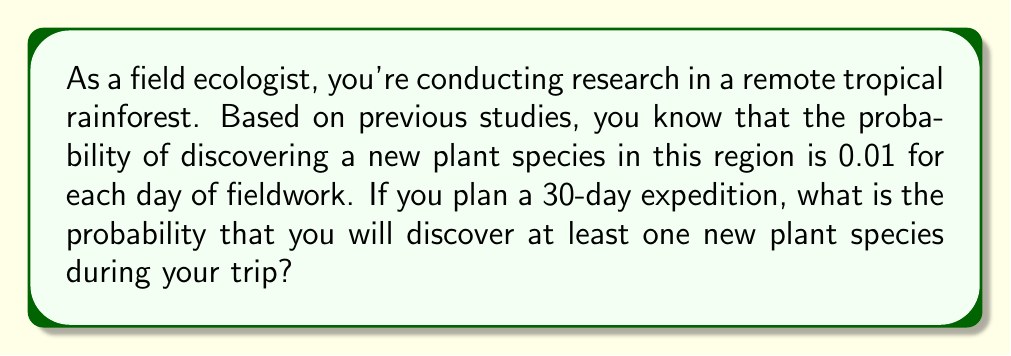Can you answer this question? Let's approach this step-by-step:

1) First, let's define our events:
   Let A be the event of discovering at least one new plant species during the 30-day trip.

2) It's easier to calculate the probability of not discovering any new species and then subtract that from 1.

3) The probability of not discovering a new species on a single day is:
   $1 - 0.01 = 0.99$

4) For the entire 30-day trip, we need the probability of not discovering a new species on any of the 30 days. Assuming independence of daily events, we can use the multiplication rule:

   $P(\text{no new species in 30 days}) = 0.99^{30}$

5) Now, we can calculate the probability of discovering at least one new species:

   $P(A) = 1 - P(\text{no new species in 30 days})$
   
   $P(A) = 1 - 0.99^{30}$

6) Let's calculate this:

   $P(A) = 1 - 0.99^{30} = 1 - 0.7397 = 0.2603$

7) Therefore, the probability of discovering at least one new plant species during the 30-day expedition is approximately 0.2603 or 26.03%.
Answer: $0.2603$ or $26.03\%$ 